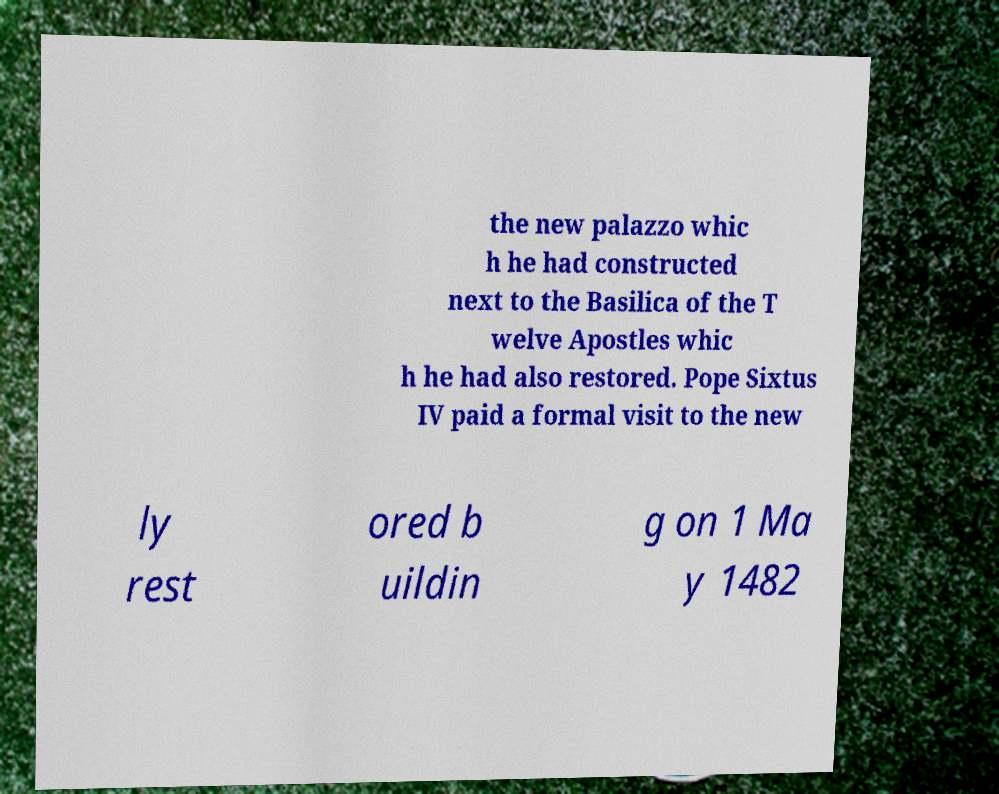There's text embedded in this image that I need extracted. Can you transcribe it verbatim? the new palazzo whic h he had constructed next to the Basilica of the T welve Apostles whic h he had also restored. Pope Sixtus IV paid a formal visit to the new ly rest ored b uildin g on 1 Ma y 1482 